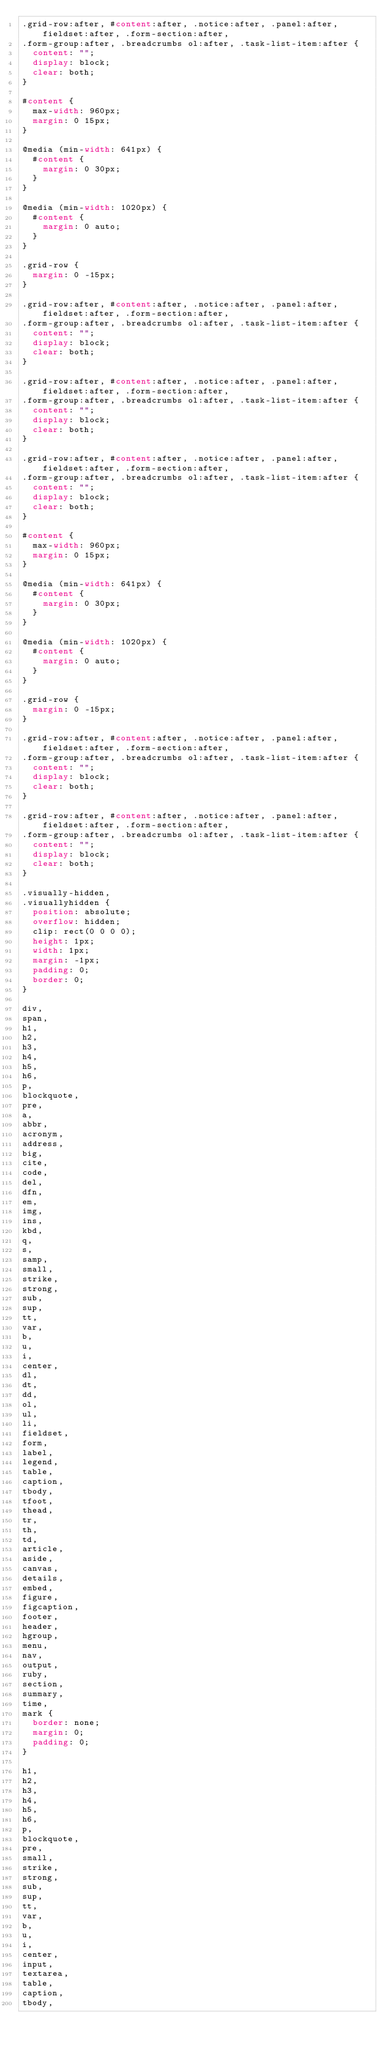Convert code to text. <code><loc_0><loc_0><loc_500><loc_500><_CSS_>.grid-row:after, #content:after, .notice:after, .panel:after, fieldset:after, .form-section:after,
.form-group:after, .breadcrumbs ol:after, .task-list-item:after {
  content: "";
  display: block;
  clear: both;
}

#content {
  max-width: 960px;
  margin: 0 15px;
}

@media (min-width: 641px) {
  #content {
    margin: 0 30px;
  }
}

@media (min-width: 1020px) {
  #content {
    margin: 0 auto;
  }
}

.grid-row {
  margin: 0 -15px;
}

.grid-row:after, #content:after, .notice:after, .panel:after, fieldset:after, .form-section:after,
.form-group:after, .breadcrumbs ol:after, .task-list-item:after {
  content: "";
  display: block;
  clear: both;
}

.grid-row:after, #content:after, .notice:after, .panel:after, fieldset:after, .form-section:after,
.form-group:after, .breadcrumbs ol:after, .task-list-item:after {
  content: "";
  display: block;
  clear: both;
}

.grid-row:after, #content:after, .notice:after, .panel:after, fieldset:after, .form-section:after,
.form-group:after, .breadcrumbs ol:after, .task-list-item:after {
  content: "";
  display: block;
  clear: both;
}

#content {
  max-width: 960px;
  margin: 0 15px;
}

@media (min-width: 641px) {
  #content {
    margin: 0 30px;
  }
}

@media (min-width: 1020px) {
  #content {
    margin: 0 auto;
  }
}

.grid-row {
  margin: 0 -15px;
}

.grid-row:after, #content:after, .notice:after, .panel:after, fieldset:after, .form-section:after,
.form-group:after, .breadcrumbs ol:after, .task-list-item:after {
  content: "";
  display: block;
  clear: both;
}

.grid-row:after, #content:after, .notice:after, .panel:after, fieldset:after, .form-section:after,
.form-group:after, .breadcrumbs ol:after, .task-list-item:after {
  content: "";
  display: block;
  clear: both;
}

.visually-hidden,
.visuallyhidden {
  position: absolute;
  overflow: hidden;
  clip: rect(0 0 0 0);
  height: 1px;
  width: 1px;
  margin: -1px;
  padding: 0;
  border: 0;
}

div,
span,
h1,
h2,
h3,
h4,
h5,
h6,
p,
blockquote,
pre,
a,
abbr,
acronym,
address,
big,
cite,
code,
del,
dfn,
em,
img,
ins,
kbd,
q,
s,
samp,
small,
strike,
strong,
sub,
sup,
tt,
var,
b,
u,
i,
center,
dl,
dt,
dd,
ol,
ul,
li,
fieldset,
form,
label,
legend,
table,
caption,
tbody,
tfoot,
thead,
tr,
th,
td,
article,
aside,
canvas,
details,
embed,
figure,
figcaption,
footer,
header,
hgroup,
menu,
nav,
output,
ruby,
section,
summary,
time,
mark {
  border: none;
  margin: 0;
  padding: 0;
}

h1,
h2,
h3,
h4,
h5,
h6,
p,
blockquote,
pre,
small,
strike,
strong,
sub,
sup,
tt,
var,
b,
u,
i,
center,
input,
textarea,
table,
caption,
tbody,</code> 